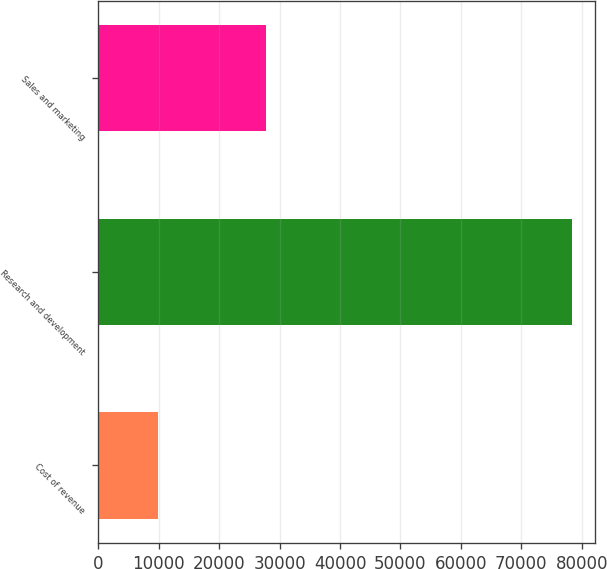<chart> <loc_0><loc_0><loc_500><loc_500><bar_chart><fcel>Cost of revenue<fcel>Research and development<fcel>Sales and marketing<nl><fcel>9831<fcel>78318<fcel>27801<nl></chart> 